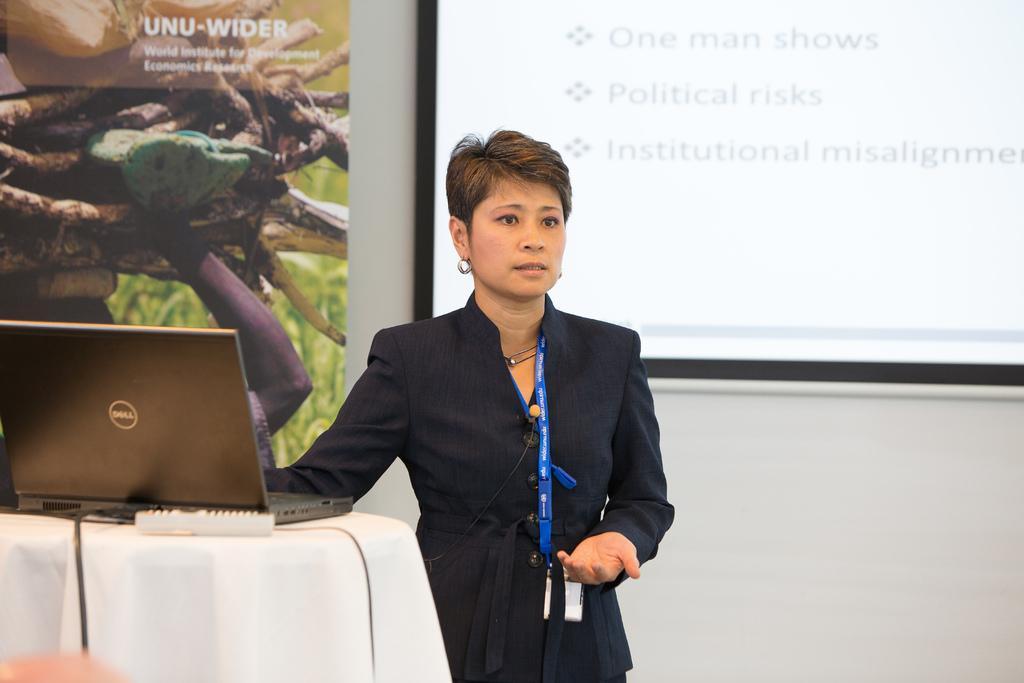Can you describe this image briefly? In this image I can see a woman standing and wearing black dress and blue tag. In front I can see a laptop,remote on the white color table. Back I can see a screen and board is attached to the white color wall. 